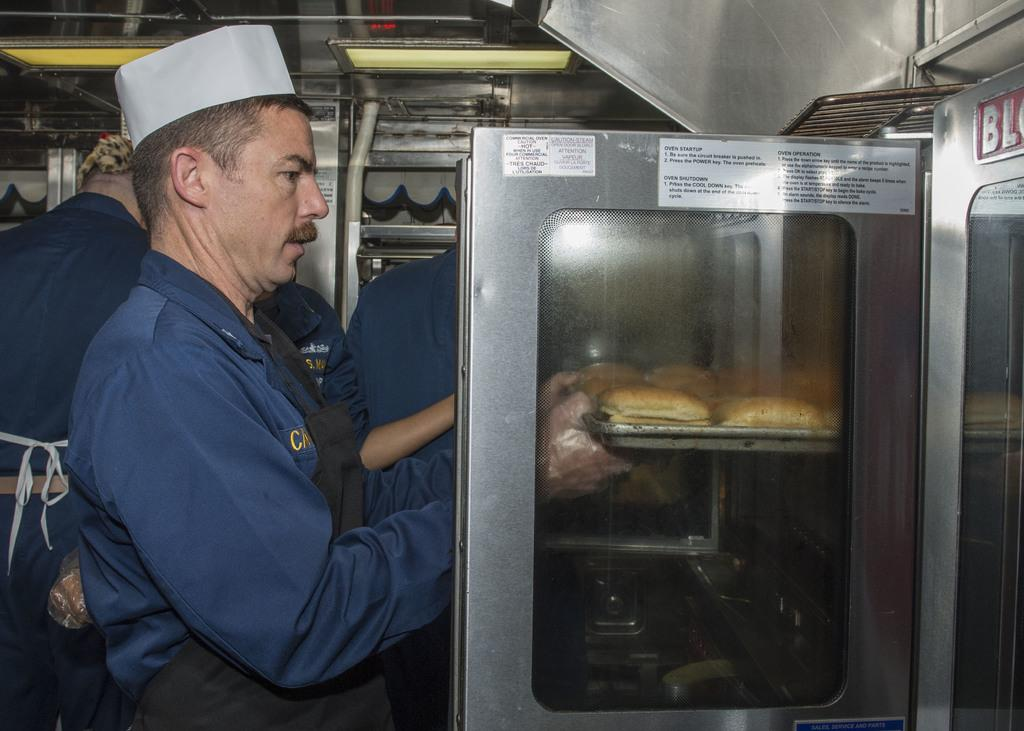Who is the main subject in the image? There is a man in the image. What is the man holding in the image? The man is holding pancakes. What is the man wearing in the image? The man is wearing a blue dress. What can be seen in the background of the image? There are many people in the background of the image. What is located to the right of the man in the image? There is an oven to the right of the man. How many oranges are on the chessboard in the image? There is no chessboard or oranges present in the image. What type of ant can be seen crawling on the man's dress in the image? There are no ants visible on the man's dress in the image. 